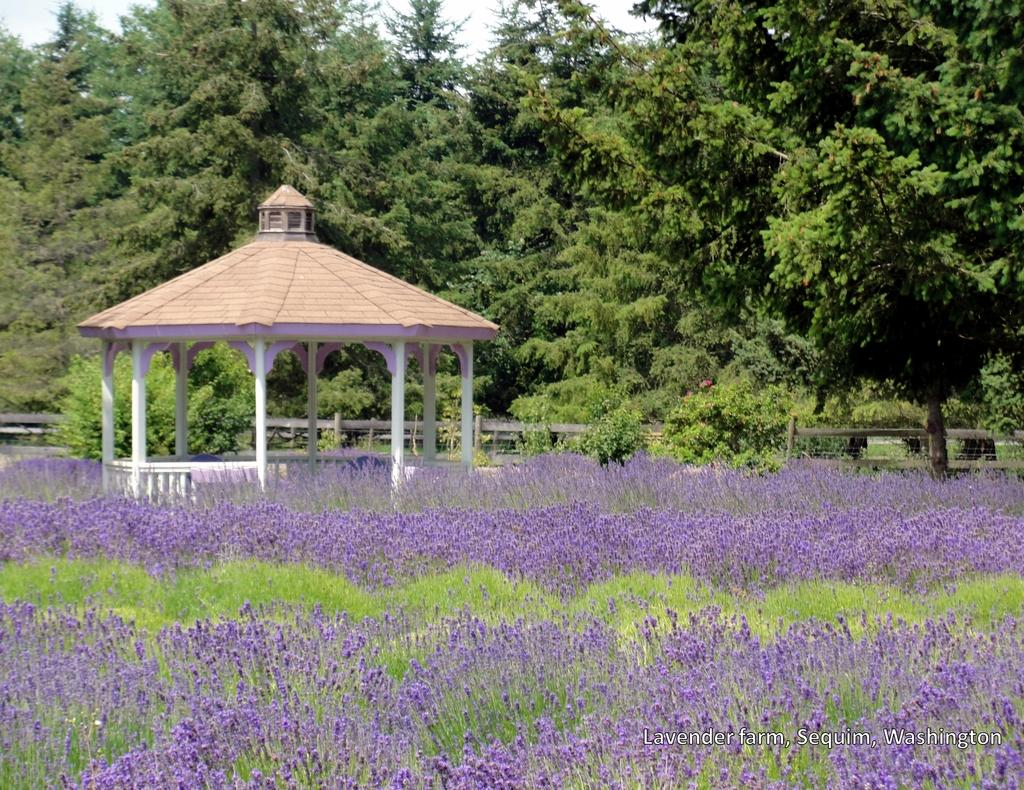What types of vegetation are at the bottom of the image? There are plants and flowers at the bottom of the image. What structure is located in the center of the image? There is a house in the center of the image. What can be seen in the background of the image? There is a fence and trees in the background of the image. Can you see any cables hanging from the trees in the image? There is no mention of cables in the image, so we cannot determine if any are present. Is there a boat visible in the image? There is no boat mentioned in the image, so we cannot determine if one is present. 